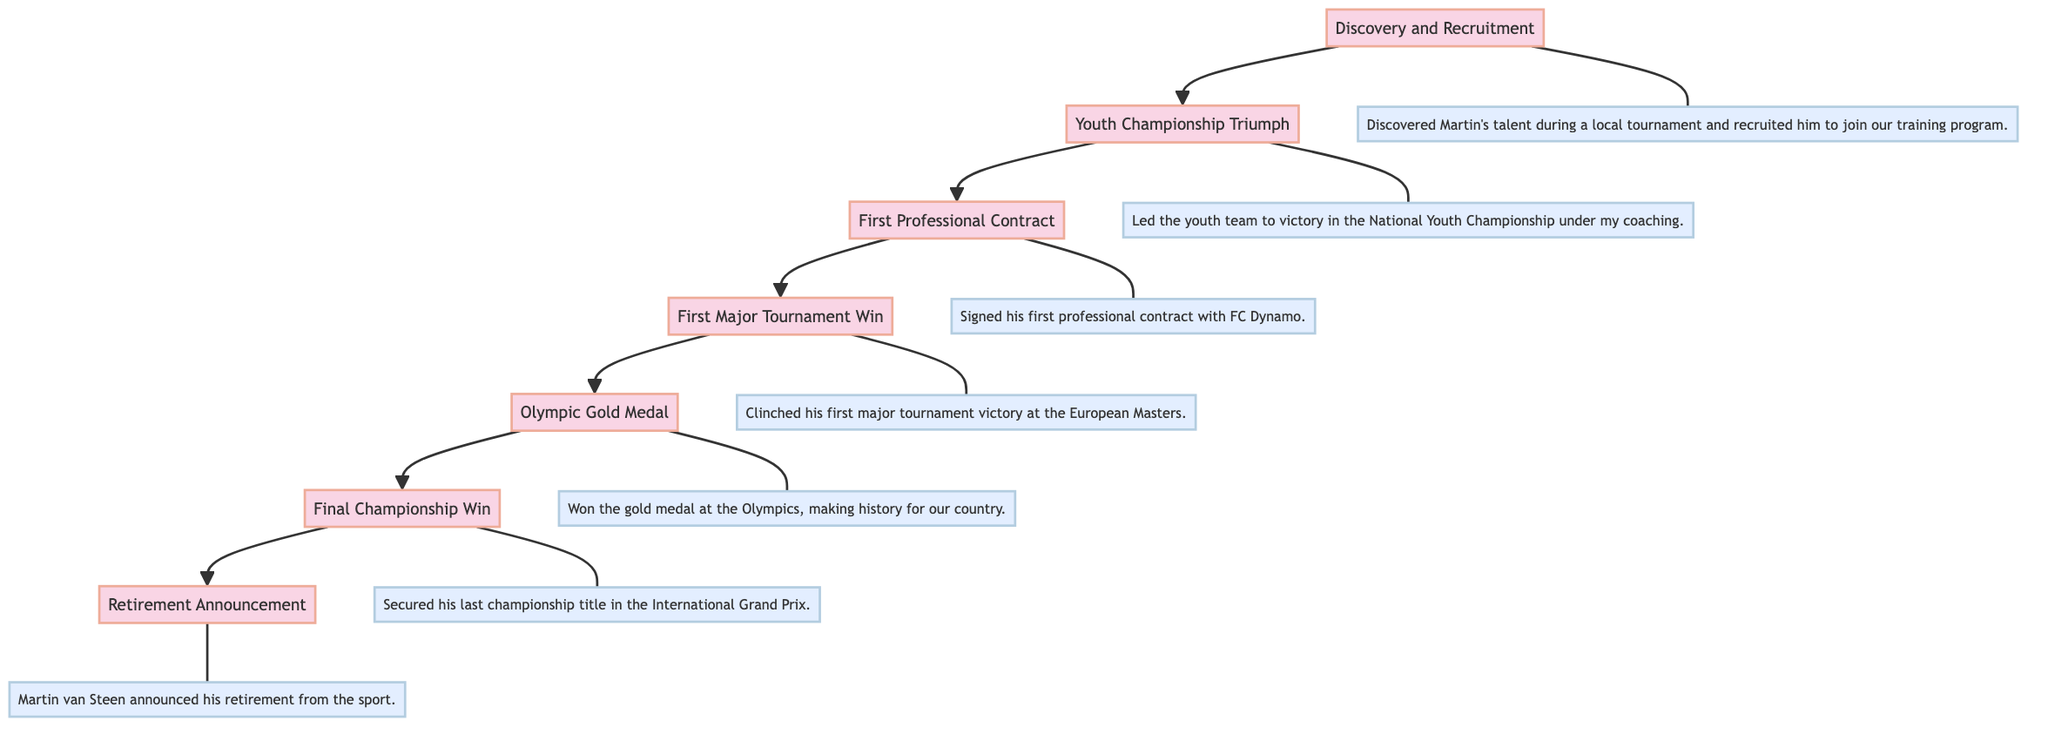What is the first key event in Martin van Steen's career path? The first key event at the bottom of the diagram is "Discovery and Recruitment," indicating that this was the starting point of his career journey.
Answer: Discovery and Recruitment How many total key events are displayed in the diagram? There are seven distinct key events in the diagram, each represented by a node.
Answer: Seven What event comes immediately after the "Youth Championship Triumph"? From the flow of the diagram, the "First Professional Contract" event follows directly after the "Youth Championship Triumph."
Answer: First Professional Contract What is the last key event in Martin van Steen's career path? The last key event listed at the top of the diagram is "Retirement Announcement," which signifies the conclusion of his career journey.
Answer: Retirement Announcement How many connections (edges) are shown in this diagram? The diagram has six connections which indicate the flow of events from one key event to the next.
Answer: Six What key event follows the "Olympic Gold Medal"? The event that comes next after "Olympic Gold Medal" in the flow is "Final Championship Win," indicating it was his subsequent achievement.
Answer: Final Championship Win What was Martin van Steen's first significant accomplishment mentioned? The first major accomplishment indicated in the diagram is "Discovery and Recruitment," marking the moment his talent was recognized and he was brought into training.
Answer: Discovery and Recruitment Which event links "First Major Tournament Win" with the "Final Championship Win"? The linking event between these two is "Olympic Gold Medal," which is placed in the flow between them in the sequence of key moments.
Answer: Olympic Gold Medal What does the "Retirement Announcement" signify in his career path? The "Retirement Announcement" at the top of the diagram signifies the end of Martin van Steen's competitive career in the sport.
Answer: End of career 